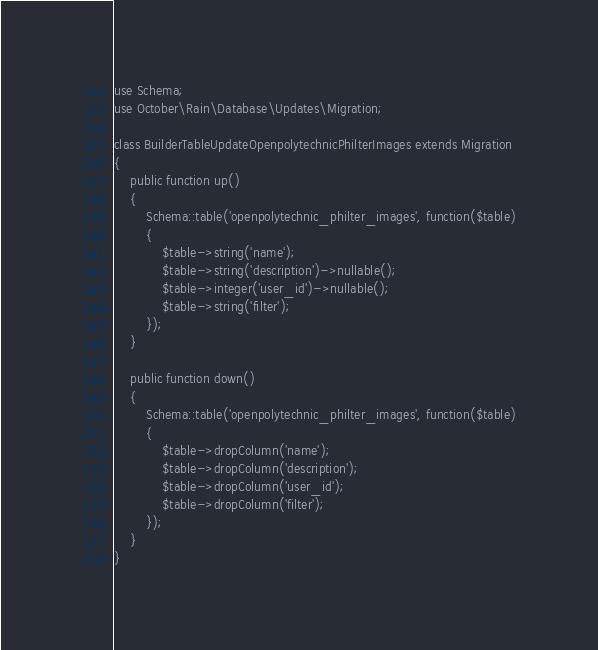Convert code to text. <code><loc_0><loc_0><loc_500><loc_500><_PHP_>
use Schema;
use October\Rain\Database\Updates\Migration;

class BuilderTableUpdateOpenpolytechnicPhilterImages extends Migration
{
    public function up()
    {
        Schema::table('openpolytechnic_philter_images', function($table)
        {
            $table->string('name');
            $table->string('description')->nullable();
            $table->integer('user_id')->nullable();
            $table->string('filter');
        });
    }
    
    public function down()
    {
        Schema::table('openpolytechnic_philter_images', function($table)
        {
            $table->dropColumn('name');
            $table->dropColumn('description');
            $table->dropColumn('user_id');
            $table->dropColumn('filter');
        });
    }
}
</code> 